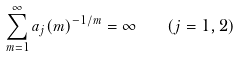<formula> <loc_0><loc_0><loc_500><loc_500>\sum _ { m = 1 } ^ { \infty } a _ { j } ( m ) ^ { - 1 / m } = \infty \quad ( j = 1 , 2 )</formula> 